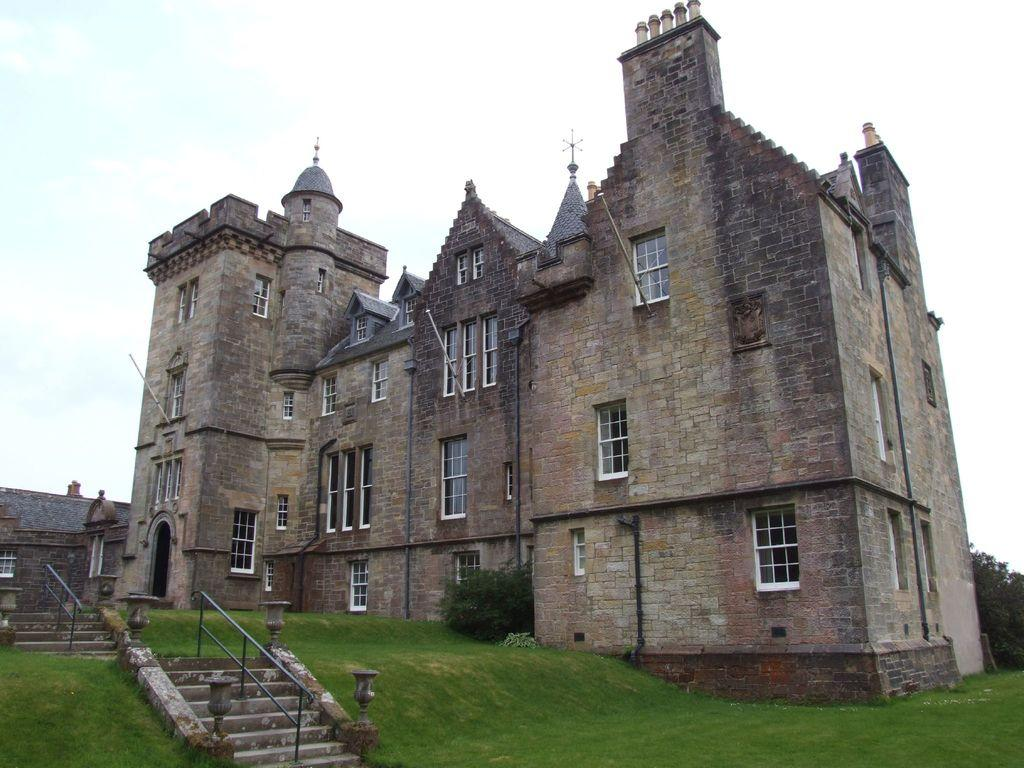What type of structure is present in the image? There is a building in the image. What architectural feature can be seen within the building? There is a staircase in the image. What type of ground surface is visible in the image? There is grass on the ground in the image. What is visible at the top of the image? The sky is visible at the top of the image. Where is the silver throne located in the image? There is no silver throne present in the image. What type of ray can be seen emanating from the building in the image? There are no rays visible in the image; it only shows a building, a staircase, grass, and the sky. 